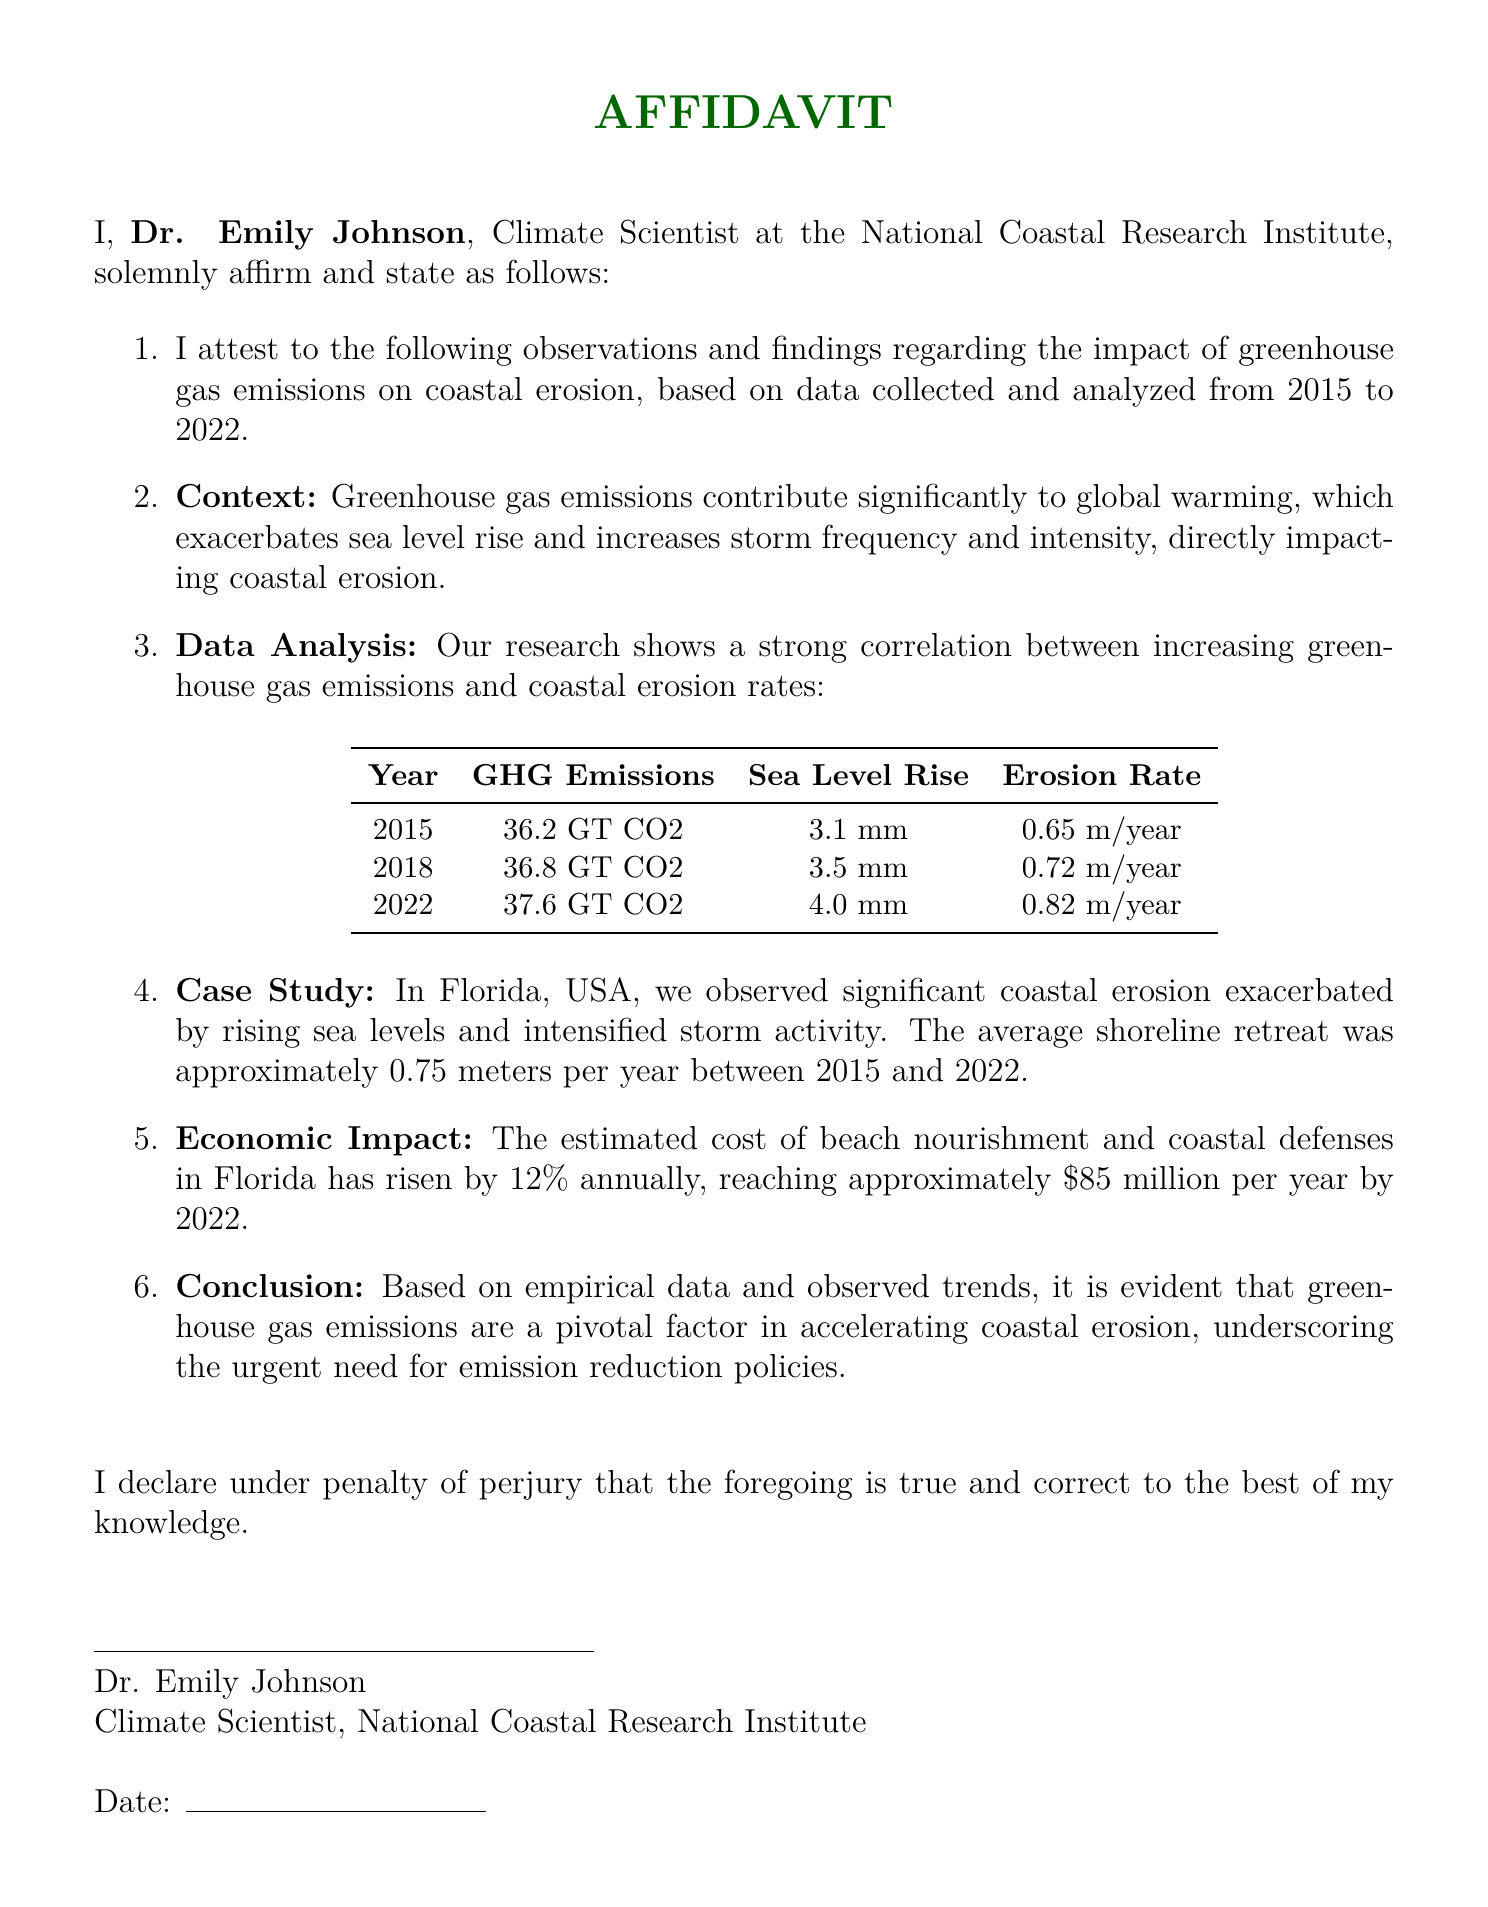What is the name of the affiant? The affiant states their name, which is Dr. Emily Johnson.
Answer: Dr. Emily Johnson What is the time period of the data analyzed? The document specifies that the data was collected and analyzed from 2015 to 2022.
Answer: 2015 to 2022 What are the greenhouse gas emissions in 2022? The document provides the emissions figure for 2022 as 37.6 GT CO2.
Answer: 37.6 GT CO2 What was the average shoreline retreat in Florida between 2015 and 2022? The average shoreline retreat mentioned in the document is approximately 0.75 meters per year.
Answer: 0.75 meters per year What percentage has the cost of beach nourishment and coastal defenses risen annually? The document states that the estimated cost has risen by 12% annually.
Answer: 12% What is the reported sea level rise in 2018? The document specifies the sea level rise for 2018 as 3.5 mm.
Answer: 3.5 mm What is the conclusion drawn from the data analyzed? The conclusion emphasizes that greenhouse gas emissions are a pivotal factor in accelerating coastal erosion.
Answer: Greenhouse gas emissions are a pivotal factor in accelerating coastal erosion What institute is Dr. Emily Johnson affiliated with? The document indicates her affiliation with the National Coastal Research Institute.
Answer: National Coastal Research Institute 